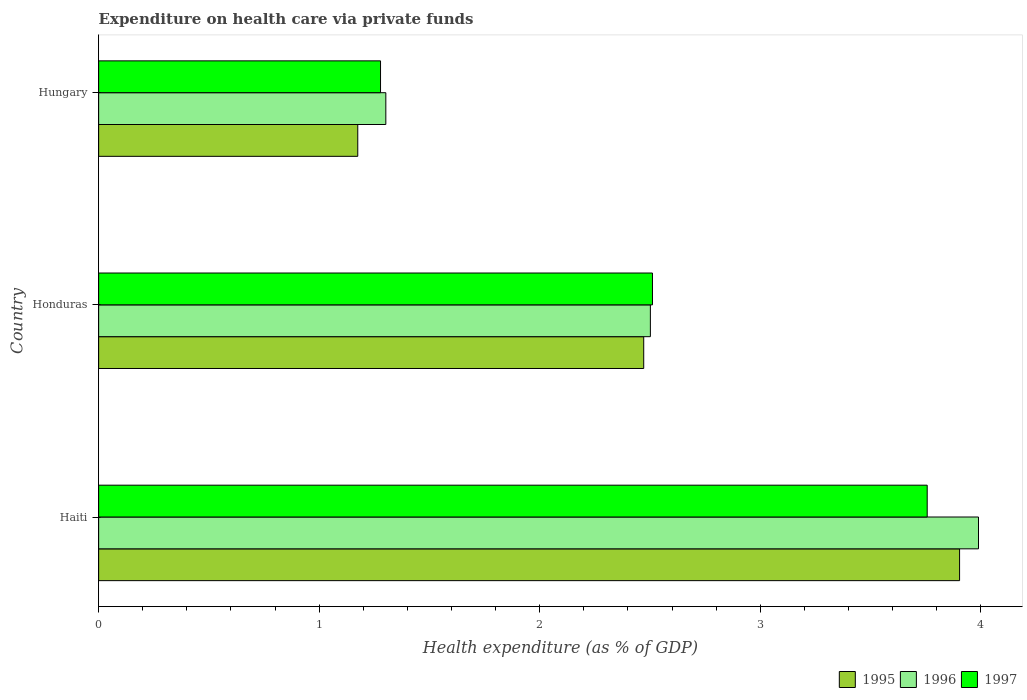How many different coloured bars are there?
Keep it short and to the point. 3. How many groups of bars are there?
Offer a terse response. 3. Are the number of bars per tick equal to the number of legend labels?
Offer a very short reply. Yes. How many bars are there on the 2nd tick from the bottom?
Your answer should be compact. 3. What is the label of the 3rd group of bars from the top?
Your answer should be compact. Haiti. In how many cases, is the number of bars for a given country not equal to the number of legend labels?
Provide a short and direct response. 0. What is the expenditure made on health care in 1995 in Hungary?
Give a very brief answer. 1.17. Across all countries, what is the maximum expenditure made on health care in 1997?
Ensure brevity in your answer.  3.76. Across all countries, what is the minimum expenditure made on health care in 1997?
Offer a terse response. 1.28. In which country was the expenditure made on health care in 1995 maximum?
Keep it short and to the point. Haiti. In which country was the expenditure made on health care in 1997 minimum?
Your answer should be compact. Hungary. What is the total expenditure made on health care in 1997 in the graph?
Give a very brief answer. 7.55. What is the difference between the expenditure made on health care in 1997 in Haiti and that in Honduras?
Your answer should be very brief. 1.25. What is the difference between the expenditure made on health care in 1997 in Honduras and the expenditure made on health care in 1996 in Haiti?
Provide a succinct answer. -1.48. What is the average expenditure made on health care in 1995 per country?
Make the answer very short. 2.52. What is the difference between the expenditure made on health care in 1997 and expenditure made on health care in 1995 in Haiti?
Provide a succinct answer. -0.15. In how many countries, is the expenditure made on health care in 1995 greater than 3.6 %?
Keep it short and to the point. 1. What is the ratio of the expenditure made on health care in 1995 in Honduras to that in Hungary?
Offer a terse response. 2.1. Is the expenditure made on health care in 1996 in Honduras less than that in Hungary?
Give a very brief answer. No. Is the difference between the expenditure made on health care in 1997 in Honduras and Hungary greater than the difference between the expenditure made on health care in 1995 in Honduras and Hungary?
Offer a terse response. No. What is the difference between the highest and the second highest expenditure made on health care in 1995?
Provide a succinct answer. 1.43. What is the difference between the highest and the lowest expenditure made on health care in 1997?
Ensure brevity in your answer.  2.48. In how many countries, is the expenditure made on health care in 1996 greater than the average expenditure made on health care in 1996 taken over all countries?
Provide a succinct answer. 1. What does the 2nd bar from the bottom in Honduras represents?
Provide a short and direct response. 1996. How many bars are there?
Provide a short and direct response. 9. How many countries are there in the graph?
Give a very brief answer. 3. Does the graph contain grids?
Make the answer very short. No. How are the legend labels stacked?
Provide a short and direct response. Horizontal. What is the title of the graph?
Give a very brief answer. Expenditure on health care via private funds. What is the label or title of the X-axis?
Offer a terse response. Health expenditure (as % of GDP). What is the Health expenditure (as % of GDP) of 1995 in Haiti?
Your response must be concise. 3.9. What is the Health expenditure (as % of GDP) of 1996 in Haiti?
Ensure brevity in your answer.  3.99. What is the Health expenditure (as % of GDP) in 1997 in Haiti?
Offer a very short reply. 3.76. What is the Health expenditure (as % of GDP) of 1995 in Honduras?
Offer a terse response. 2.47. What is the Health expenditure (as % of GDP) in 1996 in Honduras?
Provide a short and direct response. 2.5. What is the Health expenditure (as % of GDP) in 1997 in Honduras?
Ensure brevity in your answer.  2.51. What is the Health expenditure (as % of GDP) in 1995 in Hungary?
Provide a short and direct response. 1.17. What is the Health expenditure (as % of GDP) in 1996 in Hungary?
Your answer should be very brief. 1.3. What is the Health expenditure (as % of GDP) in 1997 in Hungary?
Make the answer very short. 1.28. Across all countries, what is the maximum Health expenditure (as % of GDP) of 1995?
Your answer should be compact. 3.9. Across all countries, what is the maximum Health expenditure (as % of GDP) of 1996?
Your response must be concise. 3.99. Across all countries, what is the maximum Health expenditure (as % of GDP) in 1997?
Your answer should be compact. 3.76. Across all countries, what is the minimum Health expenditure (as % of GDP) in 1995?
Make the answer very short. 1.17. Across all countries, what is the minimum Health expenditure (as % of GDP) of 1996?
Give a very brief answer. 1.3. Across all countries, what is the minimum Health expenditure (as % of GDP) in 1997?
Provide a short and direct response. 1.28. What is the total Health expenditure (as % of GDP) of 1995 in the graph?
Offer a terse response. 7.55. What is the total Health expenditure (as % of GDP) in 1996 in the graph?
Make the answer very short. 7.79. What is the total Health expenditure (as % of GDP) of 1997 in the graph?
Your response must be concise. 7.55. What is the difference between the Health expenditure (as % of GDP) of 1995 in Haiti and that in Honduras?
Your response must be concise. 1.43. What is the difference between the Health expenditure (as % of GDP) of 1996 in Haiti and that in Honduras?
Your response must be concise. 1.49. What is the difference between the Health expenditure (as % of GDP) in 1997 in Haiti and that in Honduras?
Provide a succinct answer. 1.25. What is the difference between the Health expenditure (as % of GDP) of 1995 in Haiti and that in Hungary?
Your answer should be compact. 2.73. What is the difference between the Health expenditure (as % of GDP) in 1996 in Haiti and that in Hungary?
Offer a terse response. 2.69. What is the difference between the Health expenditure (as % of GDP) of 1997 in Haiti and that in Hungary?
Make the answer very short. 2.48. What is the difference between the Health expenditure (as % of GDP) of 1995 in Honduras and that in Hungary?
Your answer should be very brief. 1.3. What is the difference between the Health expenditure (as % of GDP) of 1996 in Honduras and that in Hungary?
Offer a very short reply. 1.2. What is the difference between the Health expenditure (as % of GDP) in 1997 in Honduras and that in Hungary?
Make the answer very short. 1.23. What is the difference between the Health expenditure (as % of GDP) of 1995 in Haiti and the Health expenditure (as % of GDP) of 1996 in Honduras?
Ensure brevity in your answer.  1.4. What is the difference between the Health expenditure (as % of GDP) in 1995 in Haiti and the Health expenditure (as % of GDP) in 1997 in Honduras?
Make the answer very short. 1.39. What is the difference between the Health expenditure (as % of GDP) in 1996 in Haiti and the Health expenditure (as % of GDP) in 1997 in Honduras?
Offer a terse response. 1.48. What is the difference between the Health expenditure (as % of GDP) in 1995 in Haiti and the Health expenditure (as % of GDP) in 1996 in Hungary?
Offer a terse response. 2.6. What is the difference between the Health expenditure (as % of GDP) in 1995 in Haiti and the Health expenditure (as % of GDP) in 1997 in Hungary?
Your response must be concise. 2.63. What is the difference between the Health expenditure (as % of GDP) in 1996 in Haiti and the Health expenditure (as % of GDP) in 1997 in Hungary?
Offer a terse response. 2.71. What is the difference between the Health expenditure (as % of GDP) in 1995 in Honduras and the Health expenditure (as % of GDP) in 1996 in Hungary?
Ensure brevity in your answer.  1.17. What is the difference between the Health expenditure (as % of GDP) in 1995 in Honduras and the Health expenditure (as % of GDP) in 1997 in Hungary?
Keep it short and to the point. 1.19. What is the difference between the Health expenditure (as % of GDP) in 1996 in Honduras and the Health expenditure (as % of GDP) in 1997 in Hungary?
Offer a very short reply. 1.22. What is the average Health expenditure (as % of GDP) in 1995 per country?
Your answer should be compact. 2.52. What is the average Health expenditure (as % of GDP) of 1996 per country?
Make the answer very short. 2.6. What is the average Health expenditure (as % of GDP) of 1997 per country?
Keep it short and to the point. 2.52. What is the difference between the Health expenditure (as % of GDP) of 1995 and Health expenditure (as % of GDP) of 1996 in Haiti?
Your response must be concise. -0.09. What is the difference between the Health expenditure (as % of GDP) in 1995 and Health expenditure (as % of GDP) in 1997 in Haiti?
Ensure brevity in your answer.  0.15. What is the difference between the Health expenditure (as % of GDP) of 1996 and Health expenditure (as % of GDP) of 1997 in Haiti?
Keep it short and to the point. 0.23. What is the difference between the Health expenditure (as % of GDP) in 1995 and Health expenditure (as % of GDP) in 1996 in Honduras?
Give a very brief answer. -0.03. What is the difference between the Health expenditure (as % of GDP) of 1995 and Health expenditure (as % of GDP) of 1997 in Honduras?
Keep it short and to the point. -0.04. What is the difference between the Health expenditure (as % of GDP) of 1996 and Health expenditure (as % of GDP) of 1997 in Honduras?
Your answer should be very brief. -0.01. What is the difference between the Health expenditure (as % of GDP) in 1995 and Health expenditure (as % of GDP) in 1996 in Hungary?
Offer a terse response. -0.13. What is the difference between the Health expenditure (as % of GDP) in 1995 and Health expenditure (as % of GDP) in 1997 in Hungary?
Provide a short and direct response. -0.1. What is the difference between the Health expenditure (as % of GDP) in 1996 and Health expenditure (as % of GDP) in 1997 in Hungary?
Offer a very short reply. 0.02. What is the ratio of the Health expenditure (as % of GDP) of 1995 in Haiti to that in Honduras?
Ensure brevity in your answer.  1.58. What is the ratio of the Health expenditure (as % of GDP) in 1996 in Haiti to that in Honduras?
Your answer should be very brief. 1.59. What is the ratio of the Health expenditure (as % of GDP) of 1997 in Haiti to that in Honduras?
Give a very brief answer. 1.5. What is the ratio of the Health expenditure (as % of GDP) in 1995 in Haiti to that in Hungary?
Provide a succinct answer. 3.32. What is the ratio of the Health expenditure (as % of GDP) of 1996 in Haiti to that in Hungary?
Your answer should be compact. 3.06. What is the ratio of the Health expenditure (as % of GDP) of 1997 in Haiti to that in Hungary?
Your response must be concise. 2.94. What is the ratio of the Health expenditure (as % of GDP) in 1995 in Honduras to that in Hungary?
Your answer should be compact. 2.1. What is the ratio of the Health expenditure (as % of GDP) of 1996 in Honduras to that in Hungary?
Offer a very short reply. 1.92. What is the ratio of the Health expenditure (as % of GDP) of 1997 in Honduras to that in Hungary?
Make the answer very short. 1.96. What is the difference between the highest and the second highest Health expenditure (as % of GDP) in 1995?
Your answer should be very brief. 1.43. What is the difference between the highest and the second highest Health expenditure (as % of GDP) of 1996?
Make the answer very short. 1.49. What is the difference between the highest and the second highest Health expenditure (as % of GDP) in 1997?
Your answer should be compact. 1.25. What is the difference between the highest and the lowest Health expenditure (as % of GDP) of 1995?
Make the answer very short. 2.73. What is the difference between the highest and the lowest Health expenditure (as % of GDP) of 1996?
Provide a short and direct response. 2.69. What is the difference between the highest and the lowest Health expenditure (as % of GDP) in 1997?
Offer a very short reply. 2.48. 